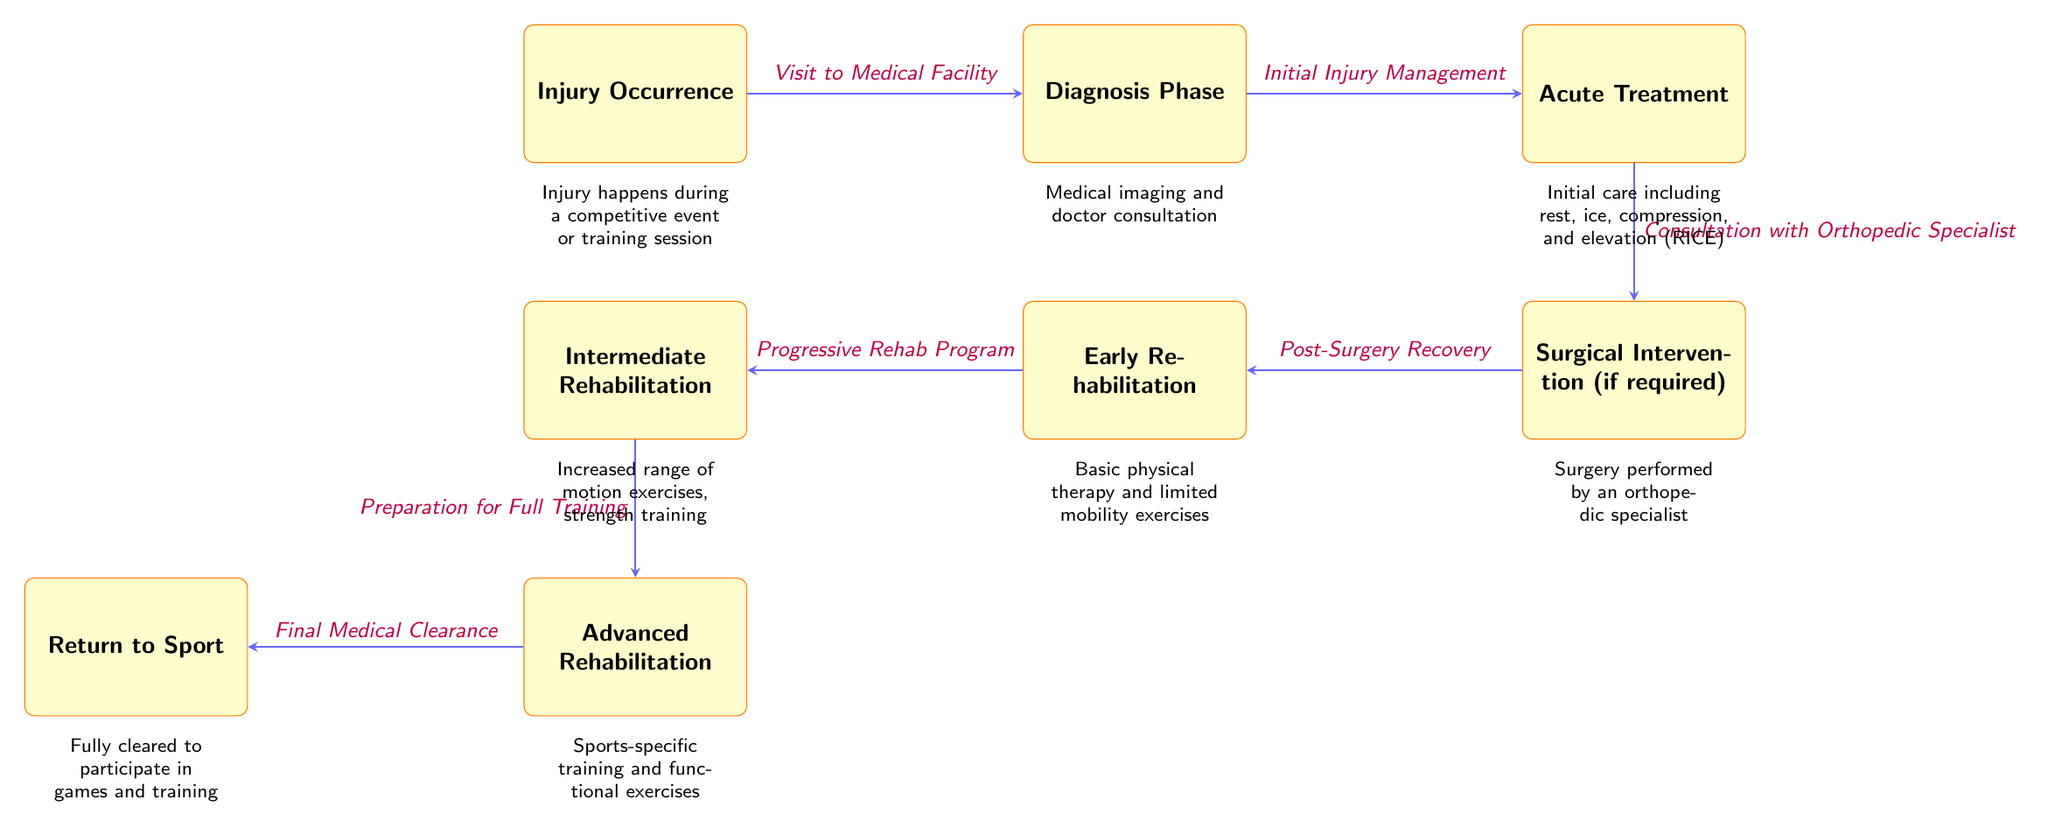What is the first stage in the injury and rehabilitation timeline? The first stage is labeled as "Injury Occurrence," which indicates the moment when the injury takes place during a competitive event or training session.
Answer: Injury Occurrence How many total stages are depicted in the diagram? The diagram displays a total of eight stages, each representing a different part of the injury and rehabilitation timeline from injury occurrence to return to sport.
Answer: Eight What follows the diagnosis phase? Following the diagnosis phase, the next stage is "Acute Treatment," which involves initial injury management steps.
Answer: Acute Treatment What type of intervention is mentioned, if required? The diagram indicates "Surgical Intervention (if required)" as a stage that occurs after "Acute Treatment," referring to the potential need for surgery based on the injury's severity.
Answer: Surgical Intervention What is the last step indicated in the rehabilitation timeline? The final step in the rehabilitation timeline is "Return to Sport," which denotes full medical clearance for the athlete to participate in games and training again.
Answer: Return to Sport What describes the treatment in the early rehabilitation stage? The early rehabilitation stage is characterized by "Basic physical therapy and limited mobility exercises," which focuses on gentle rehabilitation post-injury or surgery.
Answer: Basic physical therapy Which stage involves preparation for full training? The stage that includes preparation for full training is called "Advanced Rehabilitation," where athletes progress through exercises aimed at restoring full capability.
Answer: Advanced Rehabilitation What action occurs after "Post-Surgery Recovery"? After "Post-Surgery Recovery," the next action taken is to engage in "Early Rehabilitation," marking the beginning of the athlete's rehabilitation process following surgery.
Answer: Early Rehabilitation What is the process that begins with a visit to a medical facility? The process that begins with a visit to a medical facility is the "Diagnosis Phase," where medical imaging and a consultation with a doctor occur to assess the injury.
Answer: Diagnosis Phase 